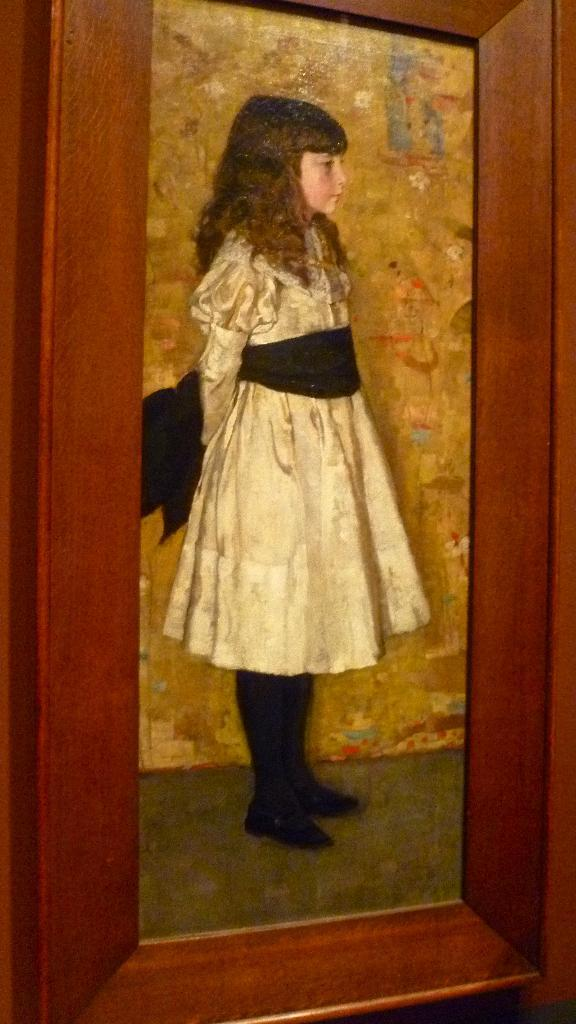What is the main subject of the image? The main subject of the image is a photo frame. Who or what is depicted in the photo frame? There is a girl in the photo frame. What is the girl wearing in the photo frame? The girl is wearing a white dress. How does the girl look in the photo frame? The girl appears stunning in the photo frame. What can be seen beside the girl in the photo frame? There is a wall beside the girl in the photo frame. Where might the photo frame be placed? The photo frame might be placed on a wall. How many friends does the girl have in the photo frame? There are no friends visible in the photo frame; it only shows the girl wearing a white dress. What arithmetic problem is the girl solving in the photo frame? There is no arithmetic problem visible in the photo frame; it only shows the girl wearing a white dress. 